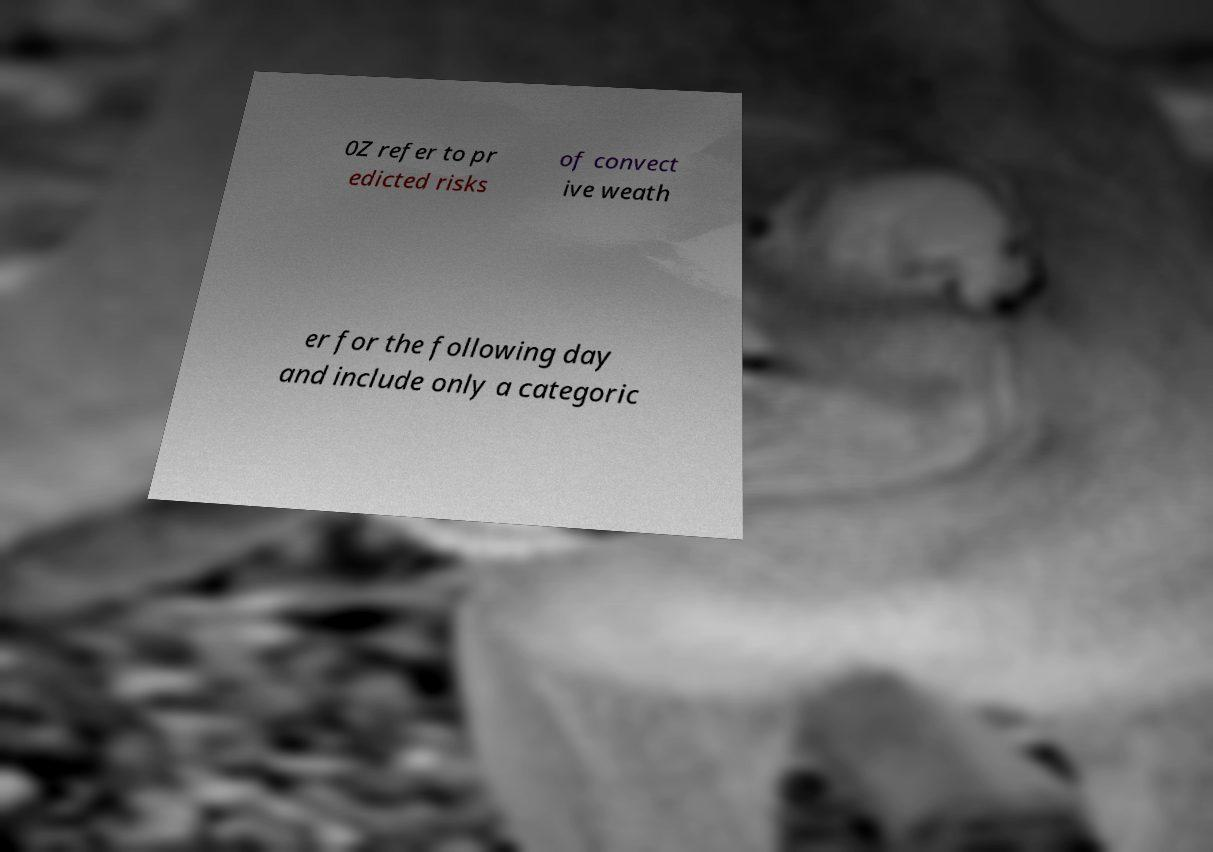For documentation purposes, I need the text within this image transcribed. Could you provide that? 0Z refer to pr edicted risks of convect ive weath er for the following day and include only a categoric 